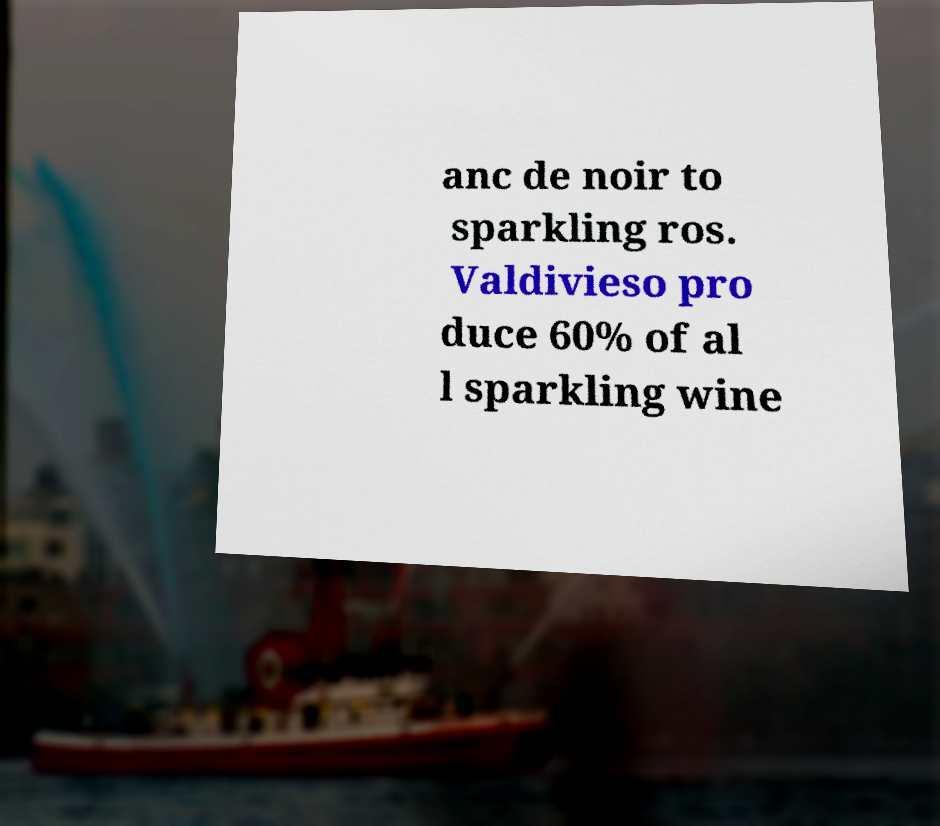Please identify and transcribe the text found in this image. anc de noir to sparkling ros. Valdivieso pro duce 60% of al l sparkling wine 